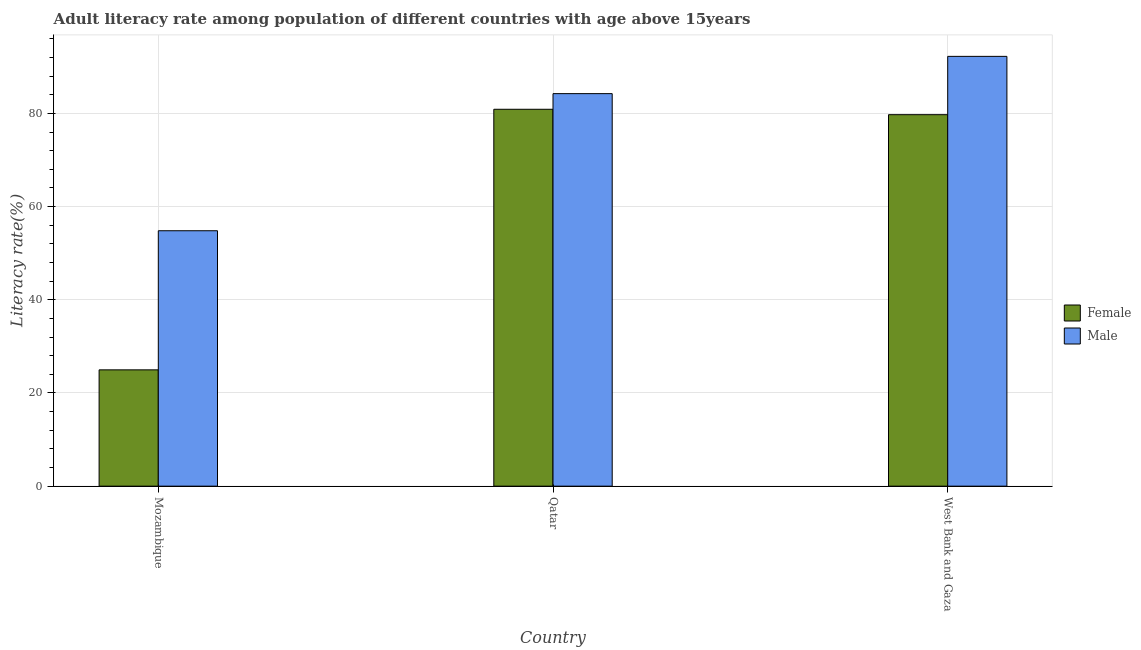How many different coloured bars are there?
Provide a succinct answer. 2. Are the number of bars per tick equal to the number of legend labels?
Your answer should be compact. Yes. Are the number of bars on each tick of the X-axis equal?
Your response must be concise. Yes. How many bars are there on the 3rd tick from the left?
Your response must be concise. 2. How many bars are there on the 3rd tick from the right?
Provide a short and direct response. 2. What is the label of the 2nd group of bars from the left?
Offer a very short reply. Qatar. In how many cases, is the number of bars for a given country not equal to the number of legend labels?
Your response must be concise. 0. What is the male adult literacy rate in Mozambique?
Make the answer very short. 54.82. Across all countries, what is the maximum male adult literacy rate?
Make the answer very short. 92.24. Across all countries, what is the minimum female adult literacy rate?
Ensure brevity in your answer.  24.96. In which country was the female adult literacy rate maximum?
Make the answer very short. Qatar. In which country was the male adult literacy rate minimum?
Give a very brief answer. Mozambique. What is the total male adult literacy rate in the graph?
Your answer should be very brief. 231.31. What is the difference between the female adult literacy rate in Qatar and that in West Bank and Gaza?
Ensure brevity in your answer.  1.16. What is the difference between the female adult literacy rate in Qatar and the male adult literacy rate in West Bank and Gaza?
Offer a terse response. -11.35. What is the average male adult literacy rate per country?
Your answer should be compact. 77.1. What is the difference between the male adult literacy rate and female adult literacy rate in Qatar?
Offer a terse response. 3.36. What is the ratio of the male adult literacy rate in Qatar to that in West Bank and Gaza?
Your answer should be compact. 0.91. What is the difference between the highest and the second highest male adult literacy rate?
Offer a terse response. 8. What is the difference between the highest and the lowest male adult literacy rate?
Offer a terse response. 37.42. What does the 1st bar from the left in Mozambique represents?
Ensure brevity in your answer.  Female. What does the 2nd bar from the right in Qatar represents?
Offer a very short reply. Female. Are all the bars in the graph horizontal?
Offer a terse response. No. Does the graph contain any zero values?
Provide a succinct answer. No. What is the title of the graph?
Provide a short and direct response. Adult literacy rate among population of different countries with age above 15years. What is the label or title of the X-axis?
Offer a very short reply. Country. What is the label or title of the Y-axis?
Make the answer very short. Literacy rate(%). What is the Literacy rate(%) in Female in Mozambique?
Keep it short and to the point. 24.96. What is the Literacy rate(%) in Male in Mozambique?
Keep it short and to the point. 54.82. What is the Literacy rate(%) in Female in Qatar?
Make the answer very short. 80.89. What is the Literacy rate(%) in Male in Qatar?
Offer a very short reply. 84.24. What is the Literacy rate(%) in Female in West Bank and Gaza?
Make the answer very short. 79.73. What is the Literacy rate(%) of Male in West Bank and Gaza?
Provide a short and direct response. 92.24. Across all countries, what is the maximum Literacy rate(%) in Female?
Your response must be concise. 80.89. Across all countries, what is the maximum Literacy rate(%) in Male?
Your answer should be very brief. 92.24. Across all countries, what is the minimum Literacy rate(%) in Female?
Ensure brevity in your answer.  24.96. Across all countries, what is the minimum Literacy rate(%) in Male?
Offer a very short reply. 54.82. What is the total Literacy rate(%) in Female in the graph?
Your answer should be very brief. 185.58. What is the total Literacy rate(%) in Male in the graph?
Your answer should be compact. 231.31. What is the difference between the Literacy rate(%) of Female in Mozambique and that in Qatar?
Offer a very short reply. -55.92. What is the difference between the Literacy rate(%) of Male in Mozambique and that in Qatar?
Offer a terse response. -29.43. What is the difference between the Literacy rate(%) of Female in Mozambique and that in West Bank and Gaza?
Offer a very short reply. -54.76. What is the difference between the Literacy rate(%) in Male in Mozambique and that in West Bank and Gaza?
Your answer should be compact. -37.42. What is the difference between the Literacy rate(%) of Female in Qatar and that in West Bank and Gaza?
Give a very brief answer. 1.16. What is the difference between the Literacy rate(%) of Male in Qatar and that in West Bank and Gaza?
Your response must be concise. -8. What is the difference between the Literacy rate(%) in Female in Mozambique and the Literacy rate(%) in Male in Qatar?
Make the answer very short. -59.28. What is the difference between the Literacy rate(%) of Female in Mozambique and the Literacy rate(%) of Male in West Bank and Gaza?
Your response must be concise. -67.28. What is the difference between the Literacy rate(%) of Female in Qatar and the Literacy rate(%) of Male in West Bank and Gaza?
Make the answer very short. -11.35. What is the average Literacy rate(%) of Female per country?
Your answer should be compact. 61.86. What is the average Literacy rate(%) of Male per country?
Offer a terse response. 77.1. What is the difference between the Literacy rate(%) of Female and Literacy rate(%) of Male in Mozambique?
Give a very brief answer. -29.85. What is the difference between the Literacy rate(%) in Female and Literacy rate(%) in Male in Qatar?
Your answer should be very brief. -3.36. What is the difference between the Literacy rate(%) of Female and Literacy rate(%) of Male in West Bank and Gaza?
Your response must be concise. -12.52. What is the ratio of the Literacy rate(%) of Female in Mozambique to that in Qatar?
Give a very brief answer. 0.31. What is the ratio of the Literacy rate(%) in Male in Mozambique to that in Qatar?
Offer a terse response. 0.65. What is the ratio of the Literacy rate(%) of Female in Mozambique to that in West Bank and Gaza?
Keep it short and to the point. 0.31. What is the ratio of the Literacy rate(%) in Male in Mozambique to that in West Bank and Gaza?
Keep it short and to the point. 0.59. What is the ratio of the Literacy rate(%) in Female in Qatar to that in West Bank and Gaza?
Your answer should be compact. 1.01. What is the ratio of the Literacy rate(%) of Male in Qatar to that in West Bank and Gaza?
Your response must be concise. 0.91. What is the difference between the highest and the second highest Literacy rate(%) of Female?
Your answer should be very brief. 1.16. What is the difference between the highest and the second highest Literacy rate(%) in Male?
Make the answer very short. 8. What is the difference between the highest and the lowest Literacy rate(%) in Female?
Ensure brevity in your answer.  55.92. What is the difference between the highest and the lowest Literacy rate(%) of Male?
Provide a succinct answer. 37.42. 